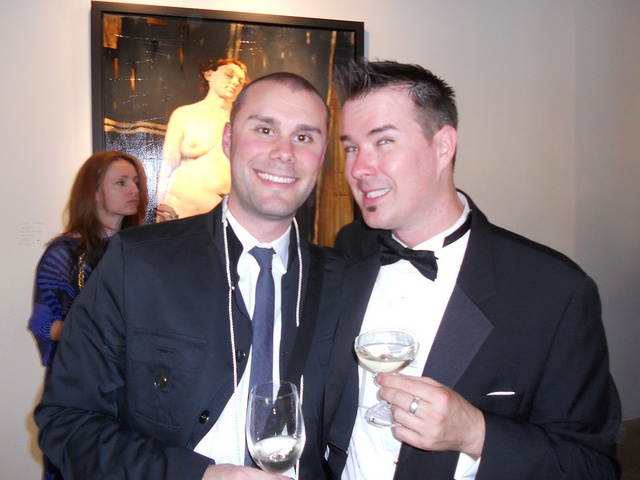Describe the objects in this image and their specific colors. I can see people in darkgray, black, white, lightpink, and gray tones, people in darkgray, black, white, and lightpink tones, people in darkgray, black, maroon, brown, and navy tones, wine glass in darkgray, gray, and white tones, and tie in darkgray and gray tones in this image. 